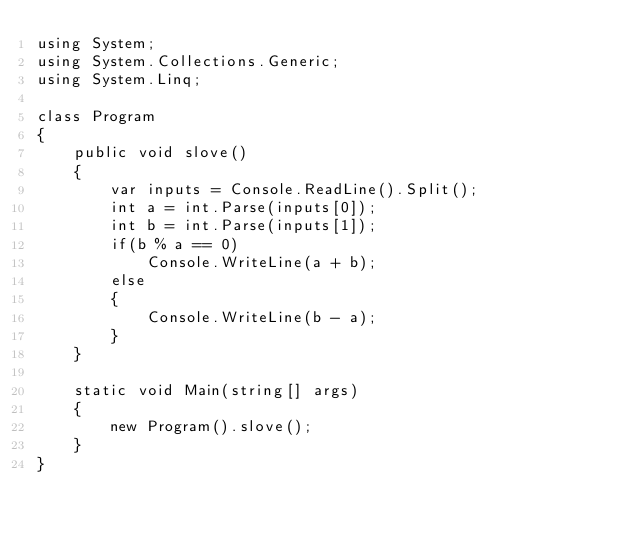Convert code to text. <code><loc_0><loc_0><loc_500><loc_500><_C#_>using System;
using System.Collections.Generic;
using System.Linq;

class Program
{
    public void slove()
    {
        var inputs = Console.ReadLine().Split();
        int a = int.Parse(inputs[0]);
        int b = int.Parse(inputs[1]);
        if(b % a == 0)
            Console.WriteLine(a + b);
        else
        {
            Console.WriteLine(b - a);
        }
    }
    
    static void Main(string[] args)
    {
        new Program().slove();
    }
}
</code> 